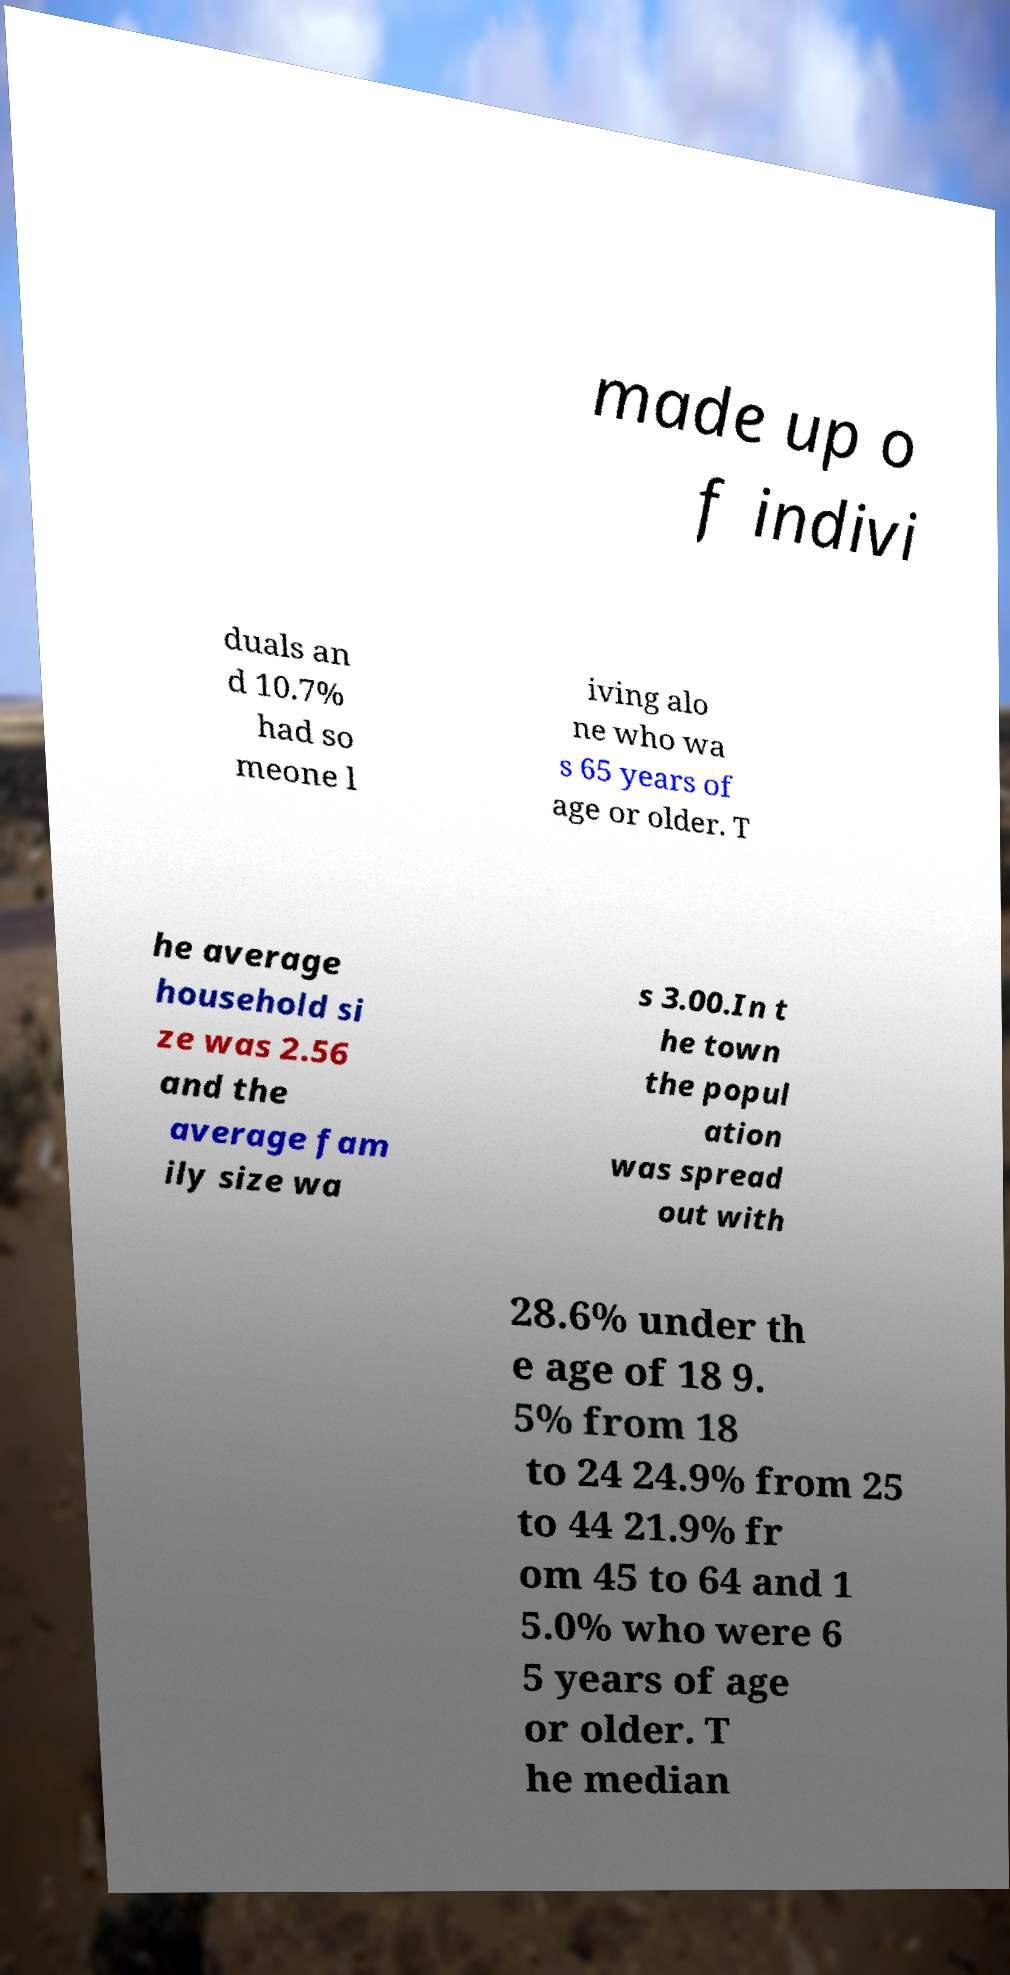Please read and relay the text visible in this image. What does it say? made up o f indivi duals an d 10.7% had so meone l iving alo ne who wa s 65 years of age or older. T he average household si ze was 2.56 and the average fam ily size wa s 3.00.In t he town the popul ation was spread out with 28.6% under th e age of 18 9. 5% from 18 to 24 24.9% from 25 to 44 21.9% fr om 45 to 64 and 1 5.0% who were 6 5 years of age or older. T he median 